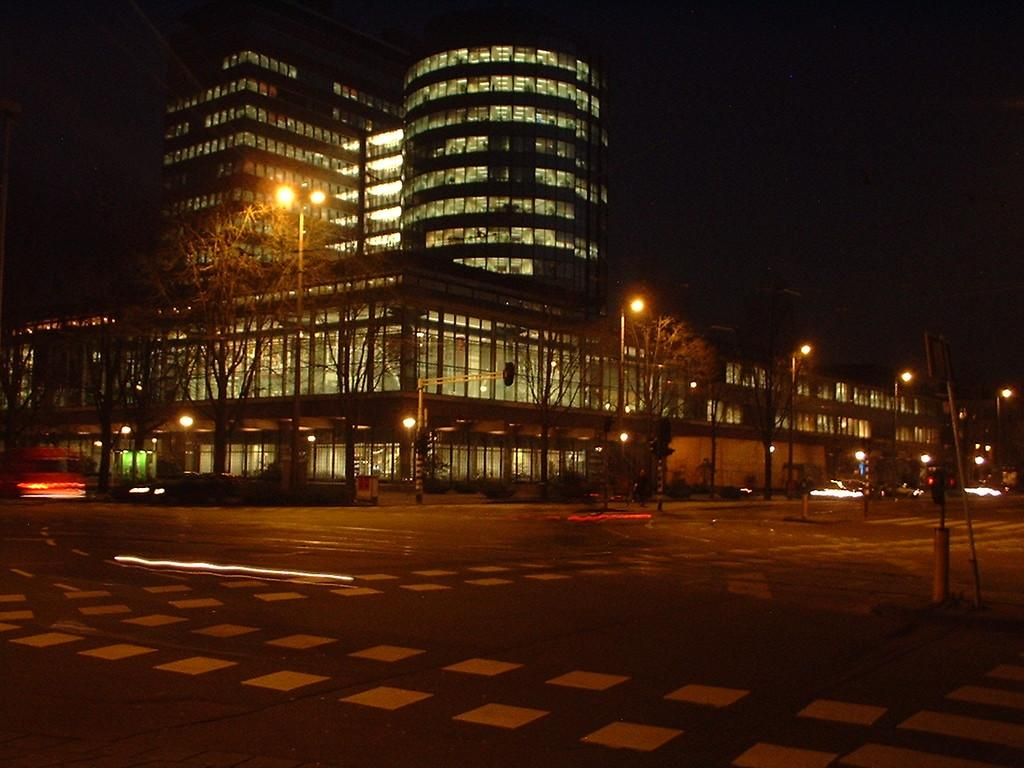Where was the image taken? The image was taken in a street. What can be seen in the foreground of the image? There is a road in the front of the image. What is visible in the background of the image? There are buildings in the background of the image. What can be observed about the buildings in the image? The buildings have many lights inside them. What type of lighting is present along the road in the image? There are street lights on the side of the road. Can you tell me how many graves are visible in the image? There are no graves visible in the image; it was taken in a street with buildings and lights. 